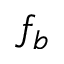Convert formula to latex. <formula><loc_0><loc_0><loc_500><loc_500>f _ { b }</formula> 